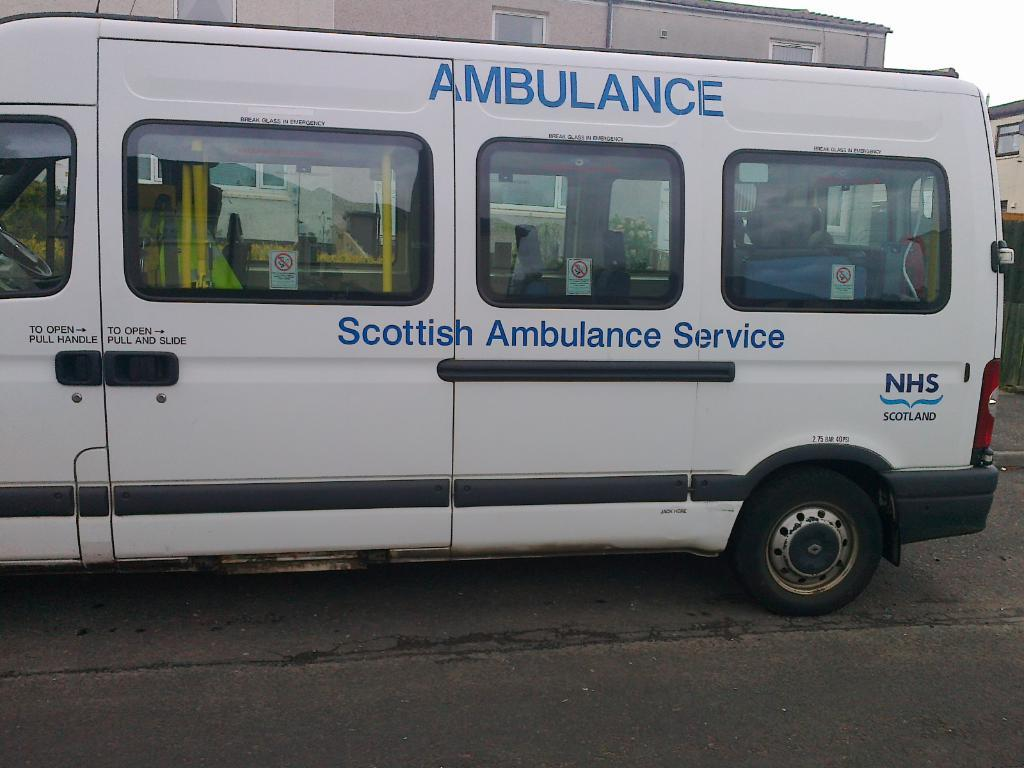<image>
Offer a succinct explanation of the picture presented. A white ambulance from the Scottish Ambulance Service. 